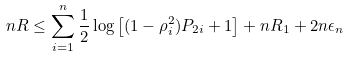Convert formula to latex. <formula><loc_0><loc_0><loc_500><loc_500>n R & \leq \sum _ { i = 1 } ^ { n } \frac { 1 } { 2 } \log \left [ ( 1 - \rho _ { i } ^ { 2 } ) P _ { 2 i } + 1 \right ] + n R _ { 1 } + 2 n \epsilon _ { n }</formula> 